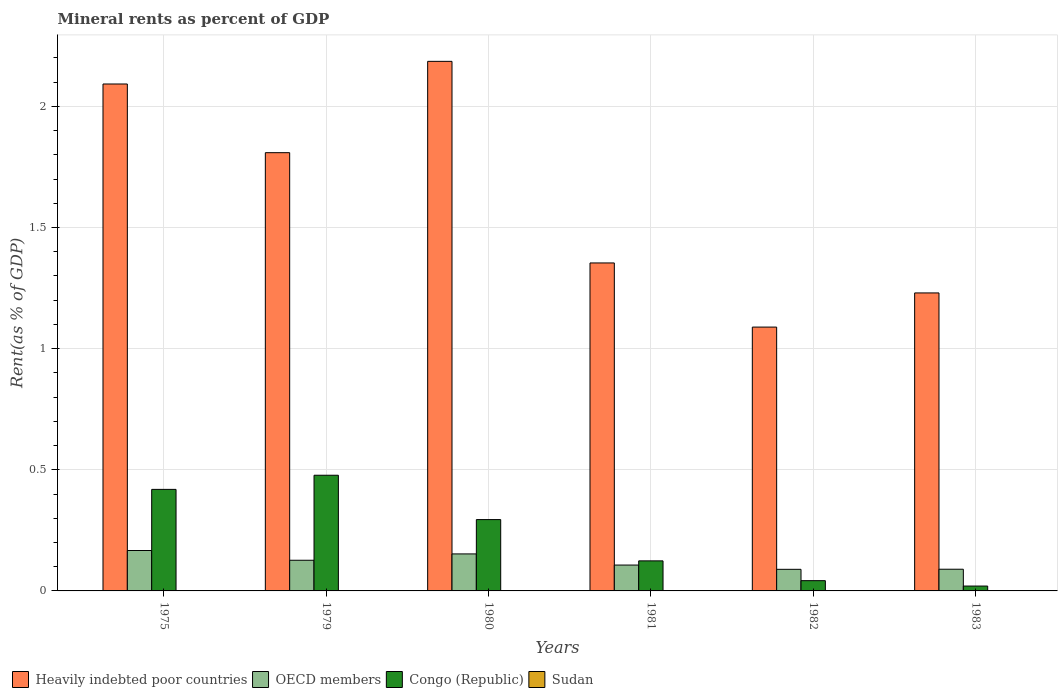How many groups of bars are there?
Offer a terse response. 6. How many bars are there on the 4th tick from the right?
Your answer should be compact. 4. What is the label of the 5th group of bars from the left?
Offer a very short reply. 1982. What is the mineral rent in OECD members in 1982?
Provide a short and direct response. 0.09. Across all years, what is the maximum mineral rent in Congo (Republic)?
Your answer should be very brief. 0.48. Across all years, what is the minimum mineral rent in Heavily indebted poor countries?
Your answer should be very brief. 1.09. In which year was the mineral rent in Heavily indebted poor countries maximum?
Give a very brief answer. 1980. What is the total mineral rent in Heavily indebted poor countries in the graph?
Give a very brief answer. 9.76. What is the difference between the mineral rent in OECD members in 1975 and that in 1983?
Your answer should be compact. 0.08. What is the difference between the mineral rent in OECD members in 1982 and the mineral rent in Heavily indebted poor countries in 1979?
Your answer should be very brief. -1.72. What is the average mineral rent in Congo (Republic) per year?
Make the answer very short. 0.23. In the year 1979, what is the difference between the mineral rent in Heavily indebted poor countries and mineral rent in Sudan?
Offer a terse response. 1.81. In how many years, is the mineral rent in OECD members greater than 1.9 %?
Your answer should be very brief. 0. What is the ratio of the mineral rent in Sudan in 1980 to that in 1981?
Offer a terse response. 2.13. Is the mineral rent in Congo (Republic) in 1980 less than that in 1981?
Keep it short and to the point. No. What is the difference between the highest and the second highest mineral rent in OECD members?
Make the answer very short. 0.01. What is the difference between the highest and the lowest mineral rent in OECD members?
Ensure brevity in your answer.  0.08. Is the sum of the mineral rent in Congo (Republic) in 1979 and 1982 greater than the maximum mineral rent in Heavily indebted poor countries across all years?
Give a very brief answer. No. What does the 4th bar from the left in 1982 represents?
Provide a short and direct response. Sudan. What does the 1st bar from the right in 1975 represents?
Your answer should be very brief. Sudan. Does the graph contain any zero values?
Provide a short and direct response. No. Where does the legend appear in the graph?
Provide a short and direct response. Bottom left. How many legend labels are there?
Provide a succinct answer. 4. What is the title of the graph?
Your answer should be very brief. Mineral rents as percent of GDP. Does "Sub-Saharan Africa (developing only)" appear as one of the legend labels in the graph?
Offer a very short reply. No. What is the label or title of the Y-axis?
Keep it short and to the point. Rent(as % of GDP). What is the Rent(as % of GDP) in Heavily indebted poor countries in 1975?
Your response must be concise. 2.09. What is the Rent(as % of GDP) in OECD members in 1975?
Provide a short and direct response. 0.17. What is the Rent(as % of GDP) in Congo (Republic) in 1975?
Your response must be concise. 0.42. What is the Rent(as % of GDP) in Sudan in 1975?
Your answer should be very brief. 1.06889651710347e-5. What is the Rent(as % of GDP) in Heavily indebted poor countries in 1979?
Keep it short and to the point. 1.81. What is the Rent(as % of GDP) in OECD members in 1979?
Ensure brevity in your answer.  0.13. What is the Rent(as % of GDP) in Congo (Republic) in 1979?
Offer a terse response. 0.48. What is the Rent(as % of GDP) of Sudan in 1979?
Offer a very short reply. 0. What is the Rent(as % of GDP) in Heavily indebted poor countries in 1980?
Provide a succinct answer. 2.19. What is the Rent(as % of GDP) in OECD members in 1980?
Your answer should be very brief. 0.15. What is the Rent(as % of GDP) in Congo (Republic) in 1980?
Provide a succinct answer. 0.29. What is the Rent(as % of GDP) of Sudan in 1980?
Ensure brevity in your answer.  0. What is the Rent(as % of GDP) of Heavily indebted poor countries in 1981?
Provide a succinct answer. 1.35. What is the Rent(as % of GDP) in OECD members in 1981?
Make the answer very short. 0.11. What is the Rent(as % of GDP) in Congo (Republic) in 1981?
Your answer should be compact. 0.12. What is the Rent(as % of GDP) in Sudan in 1981?
Ensure brevity in your answer.  0. What is the Rent(as % of GDP) of Heavily indebted poor countries in 1982?
Offer a very short reply. 1.09. What is the Rent(as % of GDP) in OECD members in 1982?
Your answer should be compact. 0.09. What is the Rent(as % of GDP) in Congo (Republic) in 1982?
Offer a very short reply. 0.04. What is the Rent(as % of GDP) in Sudan in 1982?
Offer a very short reply. 0. What is the Rent(as % of GDP) of Heavily indebted poor countries in 1983?
Your answer should be very brief. 1.23. What is the Rent(as % of GDP) in OECD members in 1983?
Your response must be concise. 0.09. What is the Rent(as % of GDP) in Congo (Republic) in 1983?
Offer a terse response. 0.02. What is the Rent(as % of GDP) in Sudan in 1983?
Give a very brief answer. 0. Across all years, what is the maximum Rent(as % of GDP) of Heavily indebted poor countries?
Give a very brief answer. 2.19. Across all years, what is the maximum Rent(as % of GDP) in OECD members?
Offer a very short reply. 0.17. Across all years, what is the maximum Rent(as % of GDP) of Congo (Republic)?
Ensure brevity in your answer.  0.48. Across all years, what is the maximum Rent(as % of GDP) of Sudan?
Ensure brevity in your answer.  0. Across all years, what is the minimum Rent(as % of GDP) in Heavily indebted poor countries?
Ensure brevity in your answer.  1.09. Across all years, what is the minimum Rent(as % of GDP) of OECD members?
Your response must be concise. 0.09. Across all years, what is the minimum Rent(as % of GDP) of Congo (Republic)?
Ensure brevity in your answer.  0.02. Across all years, what is the minimum Rent(as % of GDP) in Sudan?
Provide a succinct answer. 1.06889651710347e-5. What is the total Rent(as % of GDP) of Heavily indebted poor countries in the graph?
Your answer should be very brief. 9.76. What is the total Rent(as % of GDP) of OECD members in the graph?
Provide a succinct answer. 0.73. What is the total Rent(as % of GDP) of Congo (Republic) in the graph?
Provide a short and direct response. 1.38. What is the total Rent(as % of GDP) of Sudan in the graph?
Offer a very short reply. 0. What is the difference between the Rent(as % of GDP) in Heavily indebted poor countries in 1975 and that in 1979?
Make the answer very short. 0.28. What is the difference between the Rent(as % of GDP) of OECD members in 1975 and that in 1979?
Your response must be concise. 0.04. What is the difference between the Rent(as % of GDP) of Congo (Republic) in 1975 and that in 1979?
Make the answer very short. -0.06. What is the difference between the Rent(as % of GDP) of Sudan in 1975 and that in 1979?
Make the answer very short. -0. What is the difference between the Rent(as % of GDP) of Heavily indebted poor countries in 1975 and that in 1980?
Keep it short and to the point. -0.09. What is the difference between the Rent(as % of GDP) of OECD members in 1975 and that in 1980?
Offer a very short reply. 0.01. What is the difference between the Rent(as % of GDP) of Congo (Republic) in 1975 and that in 1980?
Make the answer very short. 0.12. What is the difference between the Rent(as % of GDP) of Sudan in 1975 and that in 1980?
Provide a succinct answer. -0. What is the difference between the Rent(as % of GDP) of Heavily indebted poor countries in 1975 and that in 1981?
Provide a short and direct response. 0.74. What is the difference between the Rent(as % of GDP) of OECD members in 1975 and that in 1981?
Provide a succinct answer. 0.06. What is the difference between the Rent(as % of GDP) of Congo (Republic) in 1975 and that in 1981?
Provide a succinct answer. 0.29. What is the difference between the Rent(as % of GDP) of Sudan in 1975 and that in 1981?
Keep it short and to the point. -0. What is the difference between the Rent(as % of GDP) in Heavily indebted poor countries in 1975 and that in 1982?
Keep it short and to the point. 1. What is the difference between the Rent(as % of GDP) in OECD members in 1975 and that in 1982?
Your answer should be compact. 0.08. What is the difference between the Rent(as % of GDP) in Congo (Republic) in 1975 and that in 1982?
Your answer should be very brief. 0.38. What is the difference between the Rent(as % of GDP) in Sudan in 1975 and that in 1982?
Your response must be concise. -0. What is the difference between the Rent(as % of GDP) of Heavily indebted poor countries in 1975 and that in 1983?
Provide a short and direct response. 0.86. What is the difference between the Rent(as % of GDP) of OECD members in 1975 and that in 1983?
Provide a succinct answer. 0.08. What is the difference between the Rent(as % of GDP) in Congo (Republic) in 1975 and that in 1983?
Provide a short and direct response. 0.4. What is the difference between the Rent(as % of GDP) in Sudan in 1975 and that in 1983?
Your response must be concise. -0. What is the difference between the Rent(as % of GDP) in Heavily indebted poor countries in 1979 and that in 1980?
Offer a very short reply. -0.38. What is the difference between the Rent(as % of GDP) in OECD members in 1979 and that in 1980?
Offer a very short reply. -0.03. What is the difference between the Rent(as % of GDP) of Congo (Republic) in 1979 and that in 1980?
Your answer should be very brief. 0.18. What is the difference between the Rent(as % of GDP) in Sudan in 1979 and that in 1980?
Your answer should be very brief. -0. What is the difference between the Rent(as % of GDP) in Heavily indebted poor countries in 1979 and that in 1981?
Offer a terse response. 0.46. What is the difference between the Rent(as % of GDP) in OECD members in 1979 and that in 1981?
Make the answer very short. 0.02. What is the difference between the Rent(as % of GDP) of Congo (Republic) in 1979 and that in 1981?
Your answer should be compact. 0.35. What is the difference between the Rent(as % of GDP) of Sudan in 1979 and that in 1981?
Your answer should be compact. -0. What is the difference between the Rent(as % of GDP) of Heavily indebted poor countries in 1979 and that in 1982?
Your answer should be compact. 0.72. What is the difference between the Rent(as % of GDP) of OECD members in 1979 and that in 1982?
Offer a terse response. 0.04. What is the difference between the Rent(as % of GDP) of Congo (Republic) in 1979 and that in 1982?
Give a very brief answer. 0.44. What is the difference between the Rent(as % of GDP) in Sudan in 1979 and that in 1982?
Keep it short and to the point. -0. What is the difference between the Rent(as % of GDP) of Heavily indebted poor countries in 1979 and that in 1983?
Keep it short and to the point. 0.58. What is the difference between the Rent(as % of GDP) of OECD members in 1979 and that in 1983?
Provide a short and direct response. 0.04. What is the difference between the Rent(as % of GDP) of Congo (Republic) in 1979 and that in 1983?
Your answer should be compact. 0.46. What is the difference between the Rent(as % of GDP) in Sudan in 1979 and that in 1983?
Provide a succinct answer. -0. What is the difference between the Rent(as % of GDP) in Heavily indebted poor countries in 1980 and that in 1981?
Your answer should be very brief. 0.83. What is the difference between the Rent(as % of GDP) of OECD members in 1980 and that in 1981?
Provide a succinct answer. 0.05. What is the difference between the Rent(as % of GDP) of Congo (Republic) in 1980 and that in 1981?
Offer a very short reply. 0.17. What is the difference between the Rent(as % of GDP) of Sudan in 1980 and that in 1981?
Offer a terse response. 0. What is the difference between the Rent(as % of GDP) in Heavily indebted poor countries in 1980 and that in 1982?
Offer a terse response. 1.1. What is the difference between the Rent(as % of GDP) in OECD members in 1980 and that in 1982?
Provide a short and direct response. 0.06. What is the difference between the Rent(as % of GDP) of Congo (Republic) in 1980 and that in 1982?
Give a very brief answer. 0.25. What is the difference between the Rent(as % of GDP) of Sudan in 1980 and that in 1982?
Ensure brevity in your answer.  0. What is the difference between the Rent(as % of GDP) of Heavily indebted poor countries in 1980 and that in 1983?
Provide a succinct answer. 0.96. What is the difference between the Rent(as % of GDP) of OECD members in 1980 and that in 1983?
Provide a succinct answer. 0.06. What is the difference between the Rent(as % of GDP) in Congo (Republic) in 1980 and that in 1983?
Ensure brevity in your answer.  0.27. What is the difference between the Rent(as % of GDP) in Sudan in 1980 and that in 1983?
Make the answer very short. 0. What is the difference between the Rent(as % of GDP) in Heavily indebted poor countries in 1981 and that in 1982?
Give a very brief answer. 0.26. What is the difference between the Rent(as % of GDP) in OECD members in 1981 and that in 1982?
Provide a short and direct response. 0.02. What is the difference between the Rent(as % of GDP) in Congo (Republic) in 1981 and that in 1982?
Provide a short and direct response. 0.08. What is the difference between the Rent(as % of GDP) of Heavily indebted poor countries in 1981 and that in 1983?
Offer a very short reply. 0.12. What is the difference between the Rent(as % of GDP) in OECD members in 1981 and that in 1983?
Your answer should be compact. 0.02. What is the difference between the Rent(as % of GDP) in Congo (Republic) in 1981 and that in 1983?
Offer a very short reply. 0.1. What is the difference between the Rent(as % of GDP) in Sudan in 1981 and that in 1983?
Keep it short and to the point. -0. What is the difference between the Rent(as % of GDP) of Heavily indebted poor countries in 1982 and that in 1983?
Offer a very short reply. -0.14. What is the difference between the Rent(as % of GDP) in OECD members in 1982 and that in 1983?
Offer a very short reply. -0. What is the difference between the Rent(as % of GDP) in Congo (Republic) in 1982 and that in 1983?
Make the answer very short. 0.02. What is the difference between the Rent(as % of GDP) in Sudan in 1982 and that in 1983?
Provide a short and direct response. -0. What is the difference between the Rent(as % of GDP) of Heavily indebted poor countries in 1975 and the Rent(as % of GDP) of OECD members in 1979?
Your response must be concise. 1.97. What is the difference between the Rent(as % of GDP) of Heavily indebted poor countries in 1975 and the Rent(as % of GDP) of Congo (Republic) in 1979?
Provide a succinct answer. 1.61. What is the difference between the Rent(as % of GDP) of Heavily indebted poor countries in 1975 and the Rent(as % of GDP) of Sudan in 1979?
Your answer should be compact. 2.09. What is the difference between the Rent(as % of GDP) of OECD members in 1975 and the Rent(as % of GDP) of Congo (Republic) in 1979?
Your answer should be compact. -0.31. What is the difference between the Rent(as % of GDP) of OECD members in 1975 and the Rent(as % of GDP) of Sudan in 1979?
Your answer should be very brief. 0.17. What is the difference between the Rent(as % of GDP) of Congo (Republic) in 1975 and the Rent(as % of GDP) of Sudan in 1979?
Provide a short and direct response. 0.42. What is the difference between the Rent(as % of GDP) in Heavily indebted poor countries in 1975 and the Rent(as % of GDP) in OECD members in 1980?
Give a very brief answer. 1.94. What is the difference between the Rent(as % of GDP) of Heavily indebted poor countries in 1975 and the Rent(as % of GDP) of Congo (Republic) in 1980?
Keep it short and to the point. 1.8. What is the difference between the Rent(as % of GDP) of Heavily indebted poor countries in 1975 and the Rent(as % of GDP) of Sudan in 1980?
Ensure brevity in your answer.  2.09. What is the difference between the Rent(as % of GDP) of OECD members in 1975 and the Rent(as % of GDP) of Congo (Republic) in 1980?
Your response must be concise. -0.13. What is the difference between the Rent(as % of GDP) in OECD members in 1975 and the Rent(as % of GDP) in Sudan in 1980?
Provide a short and direct response. 0.17. What is the difference between the Rent(as % of GDP) in Congo (Republic) in 1975 and the Rent(as % of GDP) in Sudan in 1980?
Ensure brevity in your answer.  0.42. What is the difference between the Rent(as % of GDP) in Heavily indebted poor countries in 1975 and the Rent(as % of GDP) in OECD members in 1981?
Provide a short and direct response. 1.99. What is the difference between the Rent(as % of GDP) of Heavily indebted poor countries in 1975 and the Rent(as % of GDP) of Congo (Republic) in 1981?
Ensure brevity in your answer.  1.97. What is the difference between the Rent(as % of GDP) of Heavily indebted poor countries in 1975 and the Rent(as % of GDP) of Sudan in 1981?
Your response must be concise. 2.09. What is the difference between the Rent(as % of GDP) in OECD members in 1975 and the Rent(as % of GDP) in Congo (Republic) in 1981?
Offer a terse response. 0.04. What is the difference between the Rent(as % of GDP) in OECD members in 1975 and the Rent(as % of GDP) in Sudan in 1981?
Make the answer very short. 0.17. What is the difference between the Rent(as % of GDP) in Congo (Republic) in 1975 and the Rent(as % of GDP) in Sudan in 1981?
Your response must be concise. 0.42. What is the difference between the Rent(as % of GDP) in Heavily indebted poor countries in 1975 and the Rent(as % of GDP) in OECD members in 1982?
Give a very brief answer. 2. What is the difference between the Rent(as % of GDP) in Heavily indebted poor countries in 1975 and the Rent(as % of GDP) in Congo (Republic) in 1982?
Your answer should be very brief. 2.05. What is the difference between the Rent(as % of GDP) in Heavily indebted poor countries in 1975 and the Rent(as % of GDP) in Sudan in 1982?
Offer a terse response. 2.09. What is the difference between the Rent(as % of GDP) of OECD members in 1975 and the Rent(as % of GDP) of Congo (Republic) in 1982?
Offer a very short reply. 0.12. What is the difference between the Rent(as % of GDP) in OECD members in 1975 and the Rent(as % of GDP) in Sudan in 1982?
Your response must be concise. 0.17. What is the difference between the Rent(as % of GDP) of Congo (Republic) in 1975 and the Rent(as % of GDP) of Sudan in 1982?
Your answer should be very brief. 0.42. What is the difference between the Rent(as % of GDP) in Heavily indebted poor countries in 1975 and the Rent(as % of GDP) in OECD members in 1983?
Keep it short and to the point. 2. What is the difference between the Rent(as % of GDP) of Heavily indebted poor countries in 1975 and the Rent(as % of GDP) of Congo (Republic) in 1983?
Your answer should be compact. 2.07. What is the difference between the Rent(as % of GDP) of Heavily indebted poor countries in 1975 and the Rent(as % of GDP) of Sudan in 1983?
Provide a succinct answer. 2.09. What is the difference between the Rent(as % of GDP) of OECD members in 1975 and the Rent(as % of GDP) of Congo (Republic) in 1983?
Your answer should be compact. 0.15. What is the difference between the Rent(as % of GDP) in OECD members in 1975 and the Rent(as % of GDP) in Sudan in 1983?
Offer a terse response. 0.17. What is the difference between the Rent(as % of GDP) in Congo (Republic) in 1975 and the Rent(as % of GDP) in Sudan in 1983?
Your response must be concise. 0.42. What is the difference between the Rent(as % of GDP) in Heavily indebted poor countries in 1979 and the Rent(as % of GDP) in OECD members in 1980?
Your answer should be compact. 1.66. What is the difference between the Rent(as % of GDP) in Heavily indebted poor countries in 1979 and the Rent(as % of GDP) in Congo (Republic) in 1980?
Your response must be concise. 1.51. What is the difference between the Rent(as % of GDP) of Heavily indebted poor countries in 1979 and the Rent(as % of GDP) of Sudan in 1980?
Keep it short and to the point. 1.81. What is the difference between the Rent(as % of GDP) in OECD members in 1979 and the Rent(as % of GDP) in Congo (Republic) in 1980?
Provide a short and direct response. -0.17. What is the difference between the Rent(as % of GDP) in OECD members in 1979 and the Rent(as % of GDP) in Sudan in 1980?
Provide a short and direct response. 0.13. What is the difference between the Rent(as % of GDP) in Congo (Republic) in 1979 and the Rent(as % of GDP) in Sudan in 1980?
Offer a very short reply. 0.48. What is the difference between the Rent(as % of GDP) of Heavily indebted poor countries in 1979 and the Rent(as % of GDP) of OECD members in 1981?
Your response must be concise. 1.7. What is the difference between the Rent(as % of GDP) in Heavily indebted poor countries in 1979 and the Rent(as % of GDP) in Congo (Republic) in 1981?
Offer a terse response. 1.68. What is the difference between the Rent(as % of GDP) in Heavily indebted poor countries in 1979 and the Rent(as % of GDP) in Sudan in 1981?
Ensure brevity in your answer.  1.81. What is the difference between the Rent(as % of GDP) of OECD members in 1979 and the Rent(as % of GDP) of Congo (Republic) in 1981?
Ensure brevity in your answer.  0. What is the difference between the Rent(as % of GDP) in OECD members in 1979 and the Rent(as % of GDP) in Sudan in 1981?
Offer a terse response. 0.13. What is the difference between the Rent(as % of GDP) of Congo (Republic) in 1979 and the Rent(as % of GDP) of Sudan in 1981?
Offer a very short reply. 0.48. What is the difference between the Rent(as % of GDP) in Heavily indebted poor countries in 1979 and the Rent(as % of GDP) in OECD members in 1982?
Provide a short and direct response. 1.72. What is the difference between the Rent(as % of GDP) in Heavily indebted poor countries in 1979 and the Rent(as % of GDP) in Congo (Republic) in 1982?
Your response must be concise. 1.77. What is the difference between the Rent(as % of GDP) in Heavily indebted poor countries in 1979 and the Rent(as % of GDP) in Sudan in 1982?
Ensure brevity in your answer.  1.81. What is the difference between the Rent(as % of GDP) of OECD members in 1979 and the Rent(as % of GDP) of Congo (Republic) in 1982?
Make the answer very short. 0.08. What is the difference between the Rent(as % of GDP) of OECD members in 1979 and the Rent(as % of GDP) of Sudan in 1982?
Provide a succinct answer. 0.13. What is the difference between the Rent(as % of GDP) in Congo (Republic) in 1979 and the Rent(as % of GDP) in Sudan in 1982?
Provide a short and direct response. 0.48. What is the difference between the Rent(as % of GDP) in Heavily indebted poor countries in 1979 and the Rent(as % of GDP) in OECD members in 1983?
Offer a terse response. 1.72. What is the difference between the Rent(as % of GDP) of Heavily indebted poor countries in 1979 and the Rent(as % of GDP) of Congo (Republic) in 1983?
Your answer should be compact. 1.79. What is the difference between the Rent(as % of GDP) of Heavily indebted poor countries in 1979 and the Rent(as % of GDP) of Sudan in 1983?
Give a very brief answer. 1.81. What is the difference between the Rent(as % of GDP) in OECD members in 1979 and the Rent(as % of GDP) in Congo (Republic) in 1983?
Ensure brevity in your answer.  0.11. What is the difference between the Rent(as % of GDP) of OECD members in 1979 and the Rent(as % of GDP) of Sudan in 1983?
Offer a very short reply. 0.13. What is the difference between the Rent(as % of GDP) in Congo (Republic) in 1979 and the Rent(as % of GDP) in Sudan in 1983?
Provide a short and direct response. 0.48. What is the difference between the Rent(as % of GDP) in Heavily indebted poor countries in 1980 and the Rent(as % of GDP) in OECD members in 1981?
Your response must be concise. 2.08. What is the difference between the Rent(as % of GDP) in Heavily indebted poor countries in 1980 and the Rent(as % of GDP) in Congo (Republic) in 1981?
Offer a very short reply. 2.06. What is the difference between the Rent(as % of GDP) in Heavily indebted poor countries in 1980 and the Rent(as % of GDP) in Sudan in 1981?
Offer a terse response. 2.19. What is the difference between the Rent(as % of GDP) in OECD members in 1980 and the Rent(as % of GDP) in Congo (Republic) in 1981?
Ensure brevity in your answer.  0.03. What is the difference between the Rent(as % of GDP) in OECD members in 1980 and the Rent(as % of GDP) in Sudan in 1981?
Make the answer very short. 0.15. What is the difference between the Rent(as % of GDP) in Congo (Republic) in 1980 and the Rent(as % of GDP) in Sudan in 1981?
Your response must be concise. 0.29. What is the difference between the Rent(as % of GDP) of Heavily indebted poor countries in 1980 and the Rent(as % of GDP) of OECD members in 1982?
Keep it short and to the point. 2.1. What is the difference between the Rent(as % of GDP) in Heavily indebted poor countries in 1980 and the Rent(as % of GDP) in Congo (Republic) in 1982?
Provide a short and direct response. 2.14. What is the difference between the Rent(as % of GDP) of Heavily indebted poor countries in 1980 and the Rent(as % of GDP) of Sudan in 1982?
Make the answer very short. 2.19. What is the difference between the Rent(as % of GDP) in OECD members in 1980 and the Rent(as % of GDP) in Congo (Republic) in 1982?
Your answer should be compact. 0.11. What is the difference between the Rent(as % of GDP) in OECD members in 1980 and the Rent(as % of GDP) in Sudan in 1982?
Offer a terse response. 0.15. What is the difference between the Rent(as % of GDP) in Congo (Republic) in 1980 and the Rent(as % of GDP) in Sudan in 1982?
Offer a very short reply. 0.29. What is the difference between the Rent(as % of GDP) of Heavily indebted poor countries in 1980 and the Rent(as % of GDP) of OECD members in 1983?
Your answer should be compact. 2.1. What is the difference between the Rent(as % of GDP) in Heavily indebted poor countries in 1980 and the Rent(as % of GDP) in Congo (Republic) in 1983?
Your answer should be very brief. 2.17. What is the difference between the Rent(as % of GDP) in Heavily indebted poor countries in 1980 and the Rent(as % of GDP) in Sudan in 1983?
Give a very brief answer. 2.18. What is the difference between the Rent(as % of GDP) of OECD members in 1980 and the Rent(as % of GDP) of Congo (Republic) in 1983?
Make the answer very short. 0.13. What is the difference between the Rent(as % of GDP) of OECD members in 1980 and the Rent(as % of GDP) of Sudan in 1983?
Provide a succinct answer. 0.15. What is the difference between the Rent(as % of GDP) of Congo (Republic) in 1980 and the Rent(as % of GDP) of Sudan in 1983?
Give a very brief answer. 0.29. What is the difference between the Rent(as % of GDP) of Heavily indebted poor countries in 1981 and the Rent(as % of GDP) of OECD members in 1982?
Your response must be concise. 1.26. What is the difference between the Rent(as % of GDP) in Heavily indebted poor countries in 1981 and the Rent(as % of GDP) in Congo (Republic) in 1982?
Offer a very short reply. 1.31. What is the difference between the Rent(as % of GDP) of Heavily indebted poor countries in 1981 and the Rent(as % of GDP) of Sudan in 1982?
Your answer should be compact. 1.35. What is the difference between the Rent(as % of GDP) of OECD members in 1981 and the Rent(as % of GDP) of Congo (Republic) in 1982?
Your response must be concise. 0.06. What is the difference between the Rent(as % of GDP) in OECD members in 1981 and the Rent(as % of GDP) in Sudan in 1982?
Make the answer very short. 0.11. What is the difference between the Rent(as % of GDP) of Congo (Republic) in 1981 and the Rent(as % of GDP) of Sudan in 1982?
Your answer should be very brief. 0.12. What is the difference between the Rent(as % of GDP) in Heavily indebted poor countries in 1981 and the Rent(as % of GDP) in OECD members in 1983?
Keep it short and to the point. 1.26. What is the difference between the Rent(as % of GDP) of Heavily indebted poor countries in 1981 and the Rent(as % of GDP) of Congo (Republic) in 1983?
Keep it short and to the point. 1.33. What is the difference between the Rent(as % of GDP) in Heavily indebted poor countries in 1981 and the Rent(as % of GDP) in Sudan in 1983?
Your response must be concise. 1.35. What is the difference between the Rent(as % of GDP) of OECD members in 1981 and the Rent(as % of GDP) of Congo (Republic) in 1983?
Offer a terse response. 0.09. What is the difference between the Rent(as % of GDP) in OECD members in 1981 and the Rent(as % of GDP) in Sudan in 1983?
Give a very brief answer. 0.11. What is the difference between the Rent(as % of GDP) of Congo (Republic) in 1981 and the Rent(as % of GDP) of Sudan in 1983?
Offer a terse response. 0.12. What is the difference between the Rent(as % of GDP) of Heavily indebted poor countries in 1982 and the Rent(as % of GDP) of OECD members in 1983?
Keep it short and to the point. 1. What is the difference between the Rent(as % of GDP) in Heavily indebted poor countries in 1982 and the Rent(as % of GDP) in Congo (Republic) in 1983?
Provide a succinct answer. 1.07. What is the difference between the Rent(as % of GDP) in Heavily indebted poor countries in 1982 and the Rent(as % of GDP) in Sudan in 1983?
Make the answer very short. 1.09. What is the difference between the Rent(as % of GDP) of OECD members in 1982 and the Rent(as % of GDP) of Congo (Republic) in 1983?
Offer a very short reply. 0.07. What is the difference between the Rent(as % of GDP) in OECD members in 1982 and the Rent(as % of GDP) in Sudan in 1983?
Ensure brevity in your answer.  0.09. What is the difference between the Rent(as % of GDP) of Congo (Republic) in 1982 and the Rent(as % of GDP) of Sudan in 1983?
Offer a very short reply. 0.04. What is the average Rent(as % of GDP) of Heavily indebted poor countries per year?
Your answer should be very brief. 1.63. What is the average Rent(as % of GDP) in OECD members per year?
Provide a succinct answer. 0.12. What is the average Rent(as % of GDP) in Congo (Republic) per year?
Give a very brief answer. 0.23. What is the average Rent(as % of GDP) in Sudan per year?
Make the answer very short. 0. In the year 1975, what is the difference between the Rent(as % of GDP) in Heavily indebted poor countries and Rent(as % of GDP) in OECD members?
Ensure brevity in your answer.  1.93. In the year 1975, what is the difference between the Rent(as % of GDP) of Heavily indebted poor countries and Rent(as % of GDP) of Congo (Republic)?
Provide a succinct answer. 1.67. In the year 1975, what is the difference between the Rent(as % of GDP) in Heavily indebted poor countries and Rent(as % of GDP) in Sudan?
Offer a very short reply. 2.09. In the year 1975, what is the difference between the Rent(as % of GDP) in OECD members and Rent(as % of GDP) in Congo (Republic)?
Your answer should be compact. -0.25. In the year 1975, what is the difference between the Rent(as % of GDP) of OECD members and Rent(as % of GDP) of Sudan?
Provide a succinct answer. 0.17. In the year 1975, what is the difference between the Rent(as % of GDP) of Congo (Republic) and Rent(as % of GDP) of Sudan?
Provide a short and direct response. 0.42. In the year 1979, what is the difference between the Rent(as % of GDP) of Heavily indebted poor countries and Rent(as % of GDP) of OECD members?
Give a very brief answer. 1.68. In the year 1979, what is the difference between the Rent(as % of GDP) of Heavily indebted poor countries and Rent(as % of GDP) of Congo (Republic)?
Offer a very short reply. 1.33. In the year 1979, what is the difference between the Rent(as % of GDP) in Heavily indebted poor countries and Rent(as % of GDP) in Sudan?
Offer a terse response. 1.81. In the year 1979, what is the difference between the Rent(as % of GDP) of OECD members and Rent(as % of GDP) of Congo (Republic)?
Provide a succinct answer. -0.35. In the year 1979, what is the difference between the Rent(as % of GDP) of OECD members and Rent(as % of GDP) of Sudan?
Give a very brief answer. 0.13. In the year 1979, what is the difference between the Rent(as % of GDP) in Congo (Republic) and Rent(as % of GDP) in Sudan?
Give a very brief answer. 0.48. In the year 1980, what is the difference between the Rent(as % of GDP) in Heavily indebted poor countries and Rent(as % of GDP) in OECD members?
Your answer should be very brief. 2.03. In the year 1980, what is the difference between the Rent(as % of GDP) of Heavily indebted poor countries and Rent(as % of GDP) of Congo (Republic)?
Offer a very short reply. 1.89. In the year 1980, what is the difference between the Rent(as % of GDP) in Heavily indebted poor countries and Rent(as % of GDP) in Sudan?
Your answer should be compact. 2.18. In the year 1980, what is the difference between the Rent(as % of GDP) in OECD members and Rent(as % of GDP) in Congo (Republic)?
Your response must be concise. -0.14. In the year 1980, what is the difference between the Rent(as % of GDP) in OECD members and Rent(as % of GDP) in Sudan?
Your response must be concise. 0.15. In the year 1980, what is the difference between the Rent(as % of GDP) of Congo (Republic) and Rent(as % of GDP) of Sudan?
Offer a terse response. 0.29. In the year 1981, what is the difference between the Rent(as % of GDP) in Heavily indebted poor countries and Rent(as % of GDP) in OECD members?
Keep it short and to the point. 1.25. In the year 1981, what is the difference between the Rent(as % of GDP) in Heavily indebted poor countries and Rent(as % of GDP) in Congo (Republic)?
Provide a short and direct response. 1.23. In the year 1981, what is the difference between the Rent(as % of GDP) in Heavily indebted poor countries and Rent(as % of GDP) in Sudan?
Offer a very short reply. 1.35. In the year 1981, what is the difference between the Rent(as % of GDP) in OECD members and Rent(as % of GDP) in Congo (Republic)?
Provide a short and direct response. -0.02. In the year 1981, what is the difference between the Rent(as % of GDP) in OECD members and Rent(as % of GDP) in Sudan?
Ensure brevity in your answer.  0.11. In the year 1981, what is the difference between the Rent(as % of GDP) of Congo (Republic) and Rent(as % of GDP) of Sudan?
Your answer should be compact. 0.12. In the year 1982, what is the difference between the Rent(as % of GDP) in Heavily indebted poor countries and Rent(as % of GDP) in OECD members?
Your answer should be very brief. 1. In the year 1982, what is the difference between the Rent(as % of GDP) in Heavily indebted poor countries and Rent(as % of GDP) in Congo (Republic)?
Offer a terse response. 1.05. In the year 1982, what is the difference between the Rent(as % of GDP) of Heavily indebted poor countries and Rent(as % of GDP) of Sudan?
Your answer should be very brief. 1.09. In the year 1982, what is the difference between the Rent(as % of GDP) in OECD members and Rent(as % of GDP) in Congo (Republic)?
Give a very brief answer. 0.05. In the year 1982, what is the difference between the Rent(as % of GDP) of OECD members and Rent(as % of GDP) of Sudan?
Provide a short and direct response. 0.09. In the year 1982, what is the difference between the Rent(as % of GDP) in Congo (Republic) and Rent(as % of GDP) in Sudan?
Make the answer very short. 0.04. In the year 1983, what is the difference between the Rent(as % of GDP) of Heavily indebted poor countries and Rent(as % of GDP) of OECD members?
Keep it short and to the point. 1.14. In the year 1983, what is the difference between the Rent(as % of GDP) of Heavily indebted poor countries and Rent(as % of GDP) of Congo (Republic)?
Give a very brief answer. 1.21. In the year 1983, what is the difference between the Rent(as % of GDP) in Heavily indebted poor countries and Rent(as % of GDP) in Sudan?
Give a very brief answer. 1.23. In the year 1983, what is the difference between the Rent(as % of GDP) of OECD members and Rent(as % of GDP) of Congo (Republic)?
Provide a succinct answer. 0.07. In the year 1983, what is the difference between the Rent(as % of GDP) in OECD members and Rent(as % of GDP) in Sudan?
Provide a short and direct response. 0.09. In the year 1983, what is the difference between the Rent(as % of GDP) of Congo (Republic) and Rent(as % of GDP) of Sudan?
Offer a very short reply. 0.02. What is the ratio of the Rent(as % of GDP) of Heavily indebted poor countries in 1975 to that in 1979?
Offer a terse response. 1.16. What is the ratio of the Rent(as % of GDP) in OECD members in 1975 to that in 1979?
Give a very brief answer. 1.32. What is the ratio of the Rent(as % of GDP) of Congo (Republic) in 1975 to that in 1979?
Give a very brief answer. 0.88. What is the ratio of the Rent(as % of GDP) of Sudan in 1975 to that in 1979?
Give a very brief answer. 0.04. What is the ratio of the Rent(as % of GDP) of Heavily indebted poor countries in 1975 to that in 1980?
Ensure brevity in your answer.  0.96. What is the ratio of the Rent(as % of GDP) of OECD members in 1975 to that in 1980?
Give a very brief answer. 1.09. What is the ratio of the Rent(as % of GDP) in Congo (Republic) in 1975 to that in 1980?
Offer a terse response. 1.42. What is the ratio of the Rent(as % of GDP) in Sudan in 1975 to that in 1980?
Your response must be concise. 0.01. What is the ratio of the Rent(as % of GDP) in Heavily indebted poor countries in 1975 to that in 1981?
Give a very brief answer. 1.55. What is the ratio of the Rent(as % of GDP) of OECD members in 1975 to that in 1981?
Ensure brevity in your answer.  1.56. What is the ratio of the Rent(as % of GDP) in Congo (Republic) in 1975 to that in 1981?
Keep it short and to the point. 3.38. What is the ratio of the Rent(as % of GDP) of Sudan in 1975 to that in 1981?
Offer a very short reply. 0.02. What is the ratio of the Rent(as % of GDP) of Heavily indebted poor countries in 1975 to that in 1982?
Make the answer very short. 1.92. What is the ratio of the Rent(as % of GDP) in OECD members in 1975 to that in 1982?
Your response must be concise. 1.87. What is the ratio of the Rent(as % of GDP) of Congo (Republic) in 1975 to that in 1982?
Provide a succinct answer. 9.9. What is the ratio of the Rent(as % of GDP) in Sudan in 1975 to that in 1982?
Make the answer very short. 0.02. What is the ratio of the Rent(as % of GDP) of Heavily indebted poor countries in 1975 to that in 1983?
Keep it short and to the point. 1.7. What is the ratio of the Rent(as % of GDP) of OECD members in 1975 to that in 1983?
Your response must be concise. 1.86. What is the ratio of the Rent(as % of GDP) of Congo (Republic) in 1975 to that in 1983?
Your answer should be compact. 20.86. What is the ratio of the Rent(as % of GDP) in Sudan in 1975 to that in 1983?
Provide a short and direct response. 0.01. What is the ratio of the Rent(as % of GDP) in Heavily indebted poor countries in 1979 to that in 1980?
Offer a very short reply. 0.83. What is the ratio of the Rent(as % of GDP) in OECD members in 1979 to that in 1980?
Keep it short and to the point. 0.83. What is the ratio of the Rent(as % of GDP) of Congo (Republic) in 1979 to that in 1980?
Make the answer very short. 1.62. What is the ratio of the Rent(as % of GDP) of Sudan in 1979 to that in 1980?
Your answer should be very brief. 0.2. What is the ratio of the Rent(as % of GDP) of Heavily indebted poor countries in 1979 to that in 1981?
Offer a terse response. 1.34. What is the ratio of the Rent(as % of GDP) in OECD members in 1979 to that in 1981?
Make the answer very short. 1.19. What is the ratio of the Rent(as % of GDP) in Congo (Republic) in 1979 to that in 1981?
Your response must be concise. 3.85. What is the ratio of the Rent(as % of GDP) of Sudan in 1979 to that in 1981?
Your answer should be very brief. 0.43. What is the ratio of the Rent(as % of GDP) of Heavily indebted poor countries in 1979 to that in 1982?
Give a very brief answer. 1.66. What is the ratio of the Rent(as % of GDP) in OECD members in 1979 to that in 1982?
Make the answer very short. 1.42. What is the ratio of the Rent(as % of GDP) in Congo (Republic) in 1979 to that in 1982?
Offer a terse response. 11.28. What is the ratio of the Rent(as % of GDP) of Sudan in 1979 to that in 1982?
Your answer should be very brief. 0.5. What is the ratio of the Rent(as % of GDP) of Heavily indebted poor countries in 1979 to that in 1983?
Your answer should be compact. 1.47. What is the ratio of the Rent(as % of GDP) in OECD members in 1979 to that in 1983?
Offer a very short reply. 1.41. What is the ratio of the Rent(as % of GDP) in Congo (Republic) in 1979 to that in 1983?
Give a very brief answer. 23.77. What is the ratio of the Rent(as % of GDP) of Sudan in 1979 to that in 1983?
Your answer should be very brief. 0.24. What is the ratio of the Rent(as % of GDP) of Heavily indebted poor countries in 1980 to that in 1981?
Give a very brief answer. 1.61. What is the ratio of the Rent(as % of GDP) in OECD members in 1980 to that in 1981?
Give a very brief answer. 1.43. What is the ratio of the Rent(as % of GDP) in Congo (Republic) in 1980 to that in 1981?
Ensure brevity in your answer.  2.37. What is the ratio of the Rent(as % of GDP) of Sudan in 1980 to that in 1981?
Your answer should be very brief. 2.13. What is the ratio of the Rent(as % of GDP) in Heavily indebted poor countries in 1980 to that in 1982?
Give a very brief answer. 2.01. What is the ratio of the Rent(as % of GDP) in OECD members in 1980 to that in 1982?
Provide a short and direct response. 1.71. What is the ratio of the Rent(as % of GDP) of Congo (Republic) in 1980 to that in 1982?
Offer a terse response. 6.96. What is the ratio of the Rent(as % of GDP) of Sudan in 1980 to that in 1982?
Ensure brevity in your answer.  2.44. What is the ratio of the Rent(as % of GDP) of Heavily indebted poor countries in 1980 to that in 1983?
Make the answer very short. 1.78. What is the ratio of the Rent(as % of GDP) in OECD members in 1980 to that in 1983?
Keep it short and to the point. 1.71. What is the ratio of the Rent(as % of GDP) of Congo (Republic) in 1980 to that in 1983?
Ensure brevity in your answer.  14.66. What is the ratio of the Rent(as % of GDP) of Sudan in 1980 to that in 1983?
Give a very brief answer. 1.2. What is the ratio of the Rent(as % of GDP) of Heavily indebted poor countries in 1981 to that in 1982?
Provide a succinct answer. 1.24. What is the ratio of the Rent(as % of GDP) of OECD members in 1981 to that in 1982?
Keep it short and to the point. 1.2. What is the ratio of the Rent(as % of GDP) of Congo (Republic) in 1981 to that in 1982?
Give a very brief answer. 2.93. What is the ratio of the Rent(as % of GDP) of Sudan in 1981 to that in 1982?
Offer a very short reply. 1.14. What is the ratio of the Rent(as % of GDP) of Heavily indebted poor countries in 1981 to that in 1983?
Your answer should be very brief. 1.1. What is the ratio of the Rent(as % of GDP) of OECD members in 1981 to that in 1983?
Provide a short and direct response. 1.19. What is the ratio of the Rent(as % of GDP) in Congo (Republic) in 1981 to that in 1983?
Offer a very short reply. 6.18. What is the ratio of the Rent(as % of GDP) of Sudan in 1981 to that in 1983?
Your response must be concise. 0.56. What is the ratio of the Rent(as % of GDP) of Heavily indebted poor countries in 1982 to that in 1983?
Your answer should be compact. 0.89. What is the ratio of the Rent(as % of GDP) of OECD members in 1982 to that in 1983?
Ensure brevity in your answer.  1. What is the ratio of the Rent(as % of GDP) of Congo (Republic) in 1982 to that in 1983?
Keep it short and to the point. 2.11. What is the ratio of the Rent(as % of GDP) of Sudan in 1982 to that in 1983?
Offer a terse response. 0.49. What is the difference between the highest and the second highest Rent(as % of GDP) in Heavily indebted poor countries?
Your answer should be compact. 0.09. What is the difference between the highest and the second highest Rent(as % of GDP) of OECD members?
Make the answer very short. 0.01. What is the difference between the highest and the second highest Rent(as % of GDP) of Congo (Republic)?
Provide a succinct answer. 0.06. What is the difference between the highest and the lowest Rent(as % of GDP) of Heavily indebted poor countries?
Keep it short and to the point. 1.1. What is the difference between the highest and the lowest Rent(as % of GDP) in OECD members?
Offer a terse response. 0.08. What is the difference between the highest and the lowest Rent(as % of GDP) in Congo (Republic)?
Your answer should be very brief. 0.46. What is the difference between the highest and the lowest Rent(as % of GDP) in Sudan?
Give a very brief answer. 0. 